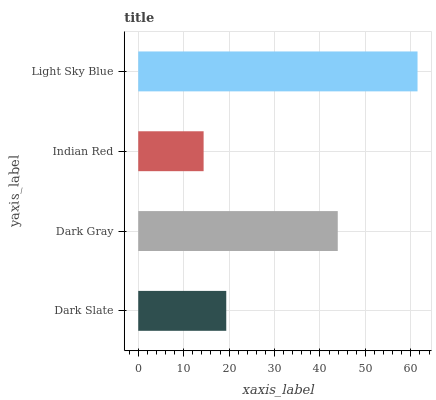Is Indian Red the minimum?
Answer yes or no. Yes. Is Light Sky Blue the maximum?
Answer yes or no. Yes. Is Dark Gray the minimum?
Answer yes or no. No. Is Dark Gray the maximum?
Answer yes or no. No. Is Dark Gray greater than Dark Slate?
Answer yes or no. Yes. Is Dark Slate less than Dark Gray?
Answer yes or no. Yes. Is Dark Slate greater than Dark Gray?
Answer yes or no. No. Is Dark Gray less than Dark Slate?
Answer yes or no. No. Is Dark Gray the high median?
Answer yes or no. Yes. Is Dark Slate the low median?
Answer yes or no. Yes. Is Dark Slate the high median?
Answer yes or no. No. Is Light Sky Blue the low median?
Answer yes or no. No. 